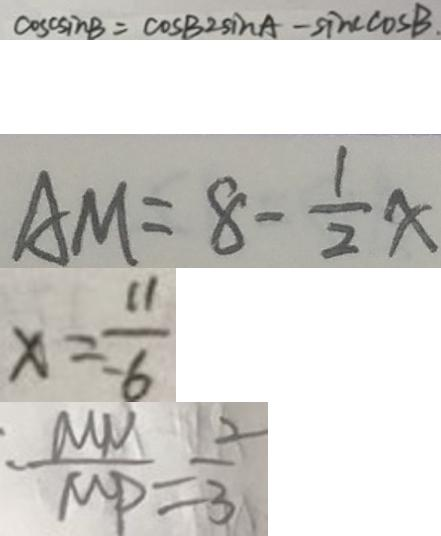<formula> <loc_0><loc_0><loc_500><loc_500>\cos c \sin B - \cos c 2 \sin A - \cos c \sin B . 
 A M = 8 - \frac { 1 } { 2 } x 
 x = \frac { 1 1 } { - 6 } 
 \frac { M N } { M P } = \frac { 2 } { 3 }</formula> 